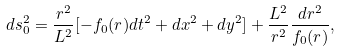Convert formula to latex. <formula><loc_0><loc_0><loc_500><loc_500>d s _ { 0 } ^ { 2 } = \frac { r ^ { 2 } } { L ^ { 2 } } [ - f _ { 0 } ( r ) d t ^ { 2 } + d x ^ { 2 } + d y ^ { 2 } ] + \frac { L ^ { 2 } } { r ^ { 2 } } \frac { d r ^ { 2 } } { f _ { 0 } ( r ) } ,</formula> 